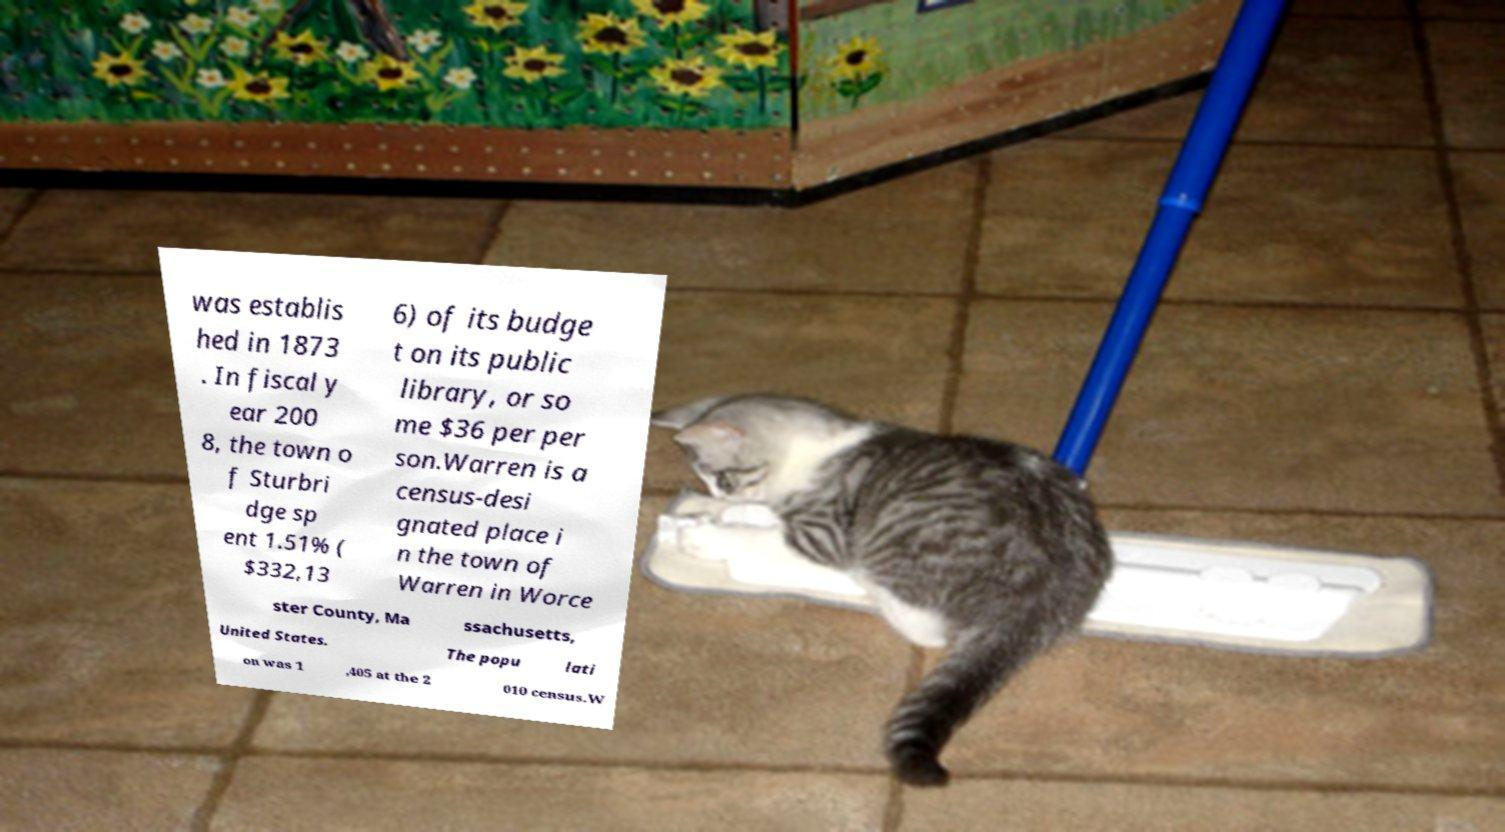There's text embedded in this image that I need extracted. Can you transcribe it verbatim? was establis hed in 1873 . In fiscal y ear 200 8, the town o f Sturbri dge sp ent 1.51% ( $332,13 6) of its budge t on its public library, or so me $36 per per son.Warren is a census-desi gnated place i n the town of Warren in Worce ster County, Ma ssachusetts, United States. The popu lati on was 1 ,405 at the 2 010 census.W 